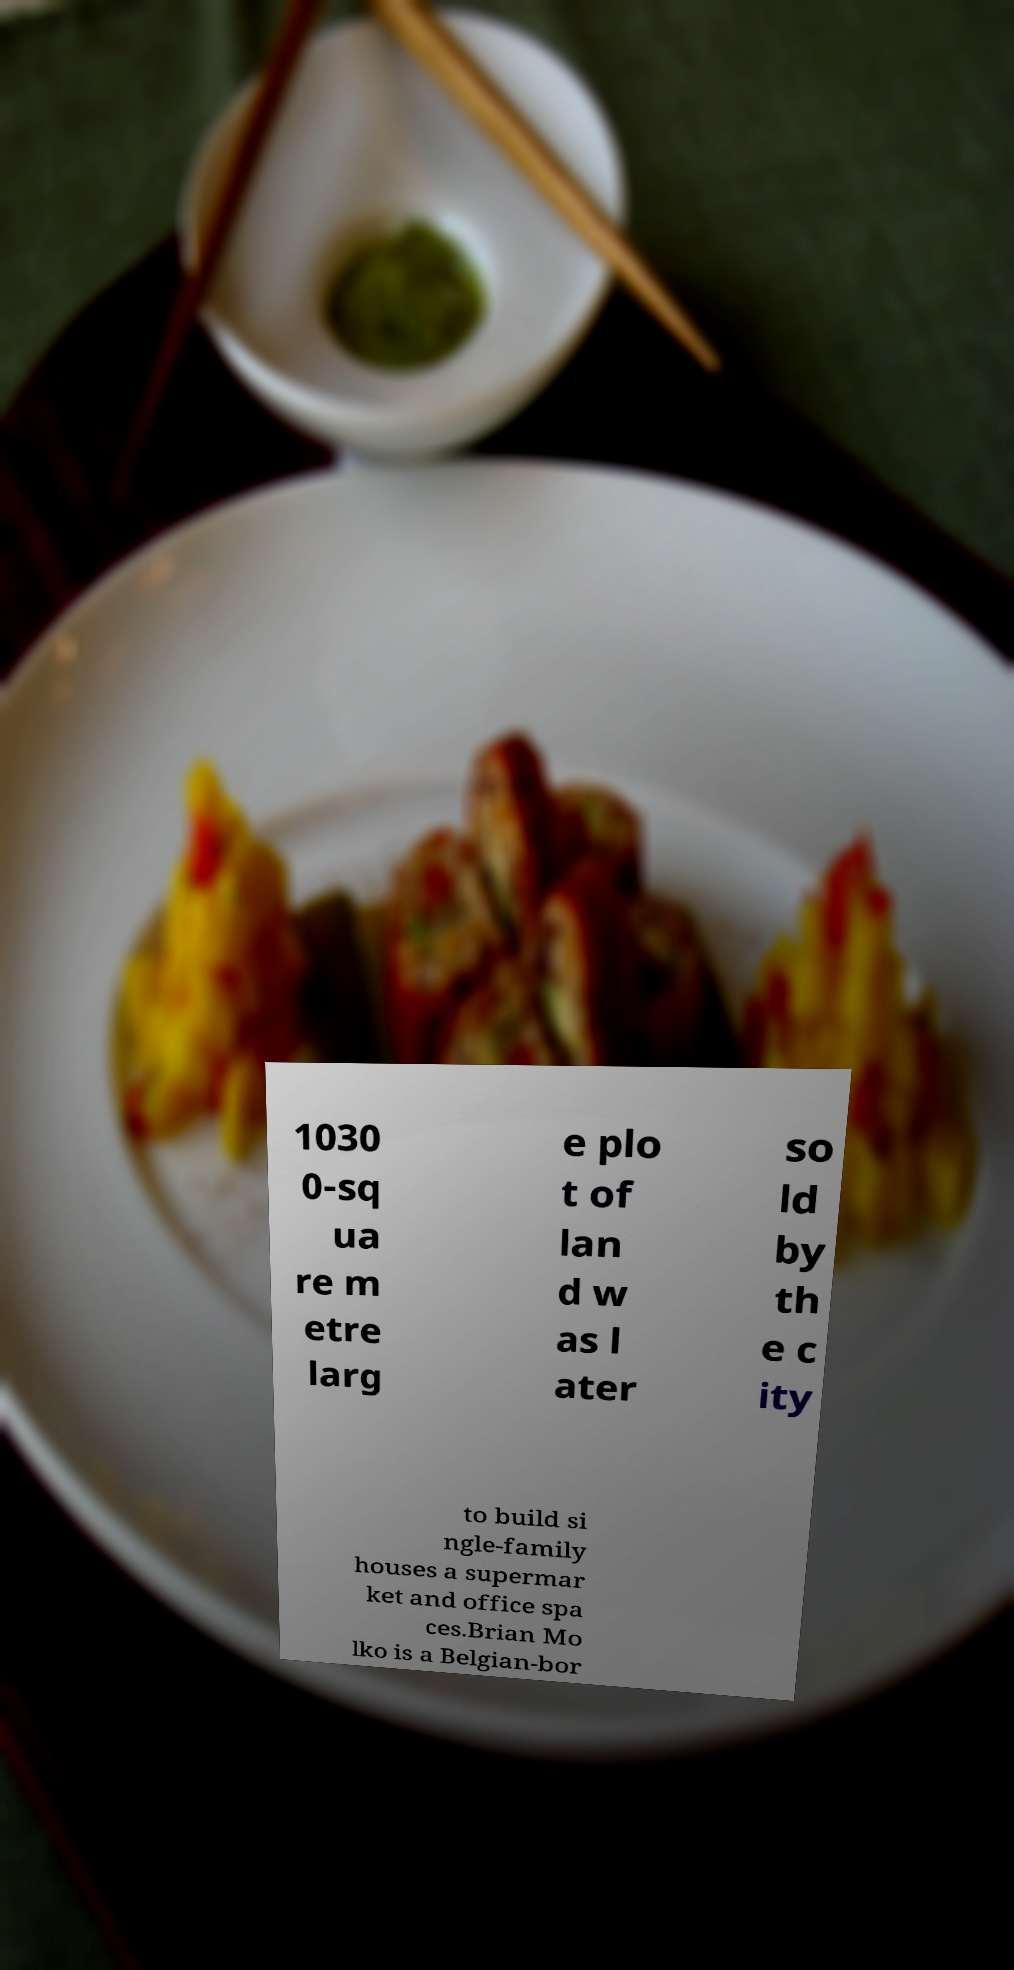I need the written content from this picture converted into text. Can you do that? 1030 0-sq ua re m etre larg e plo t of lan d w as l ater so ld by th e c ity to build si ngle-family houses a supermar ket and office spa ces.Brian Mo lko is a Belgian-bor 